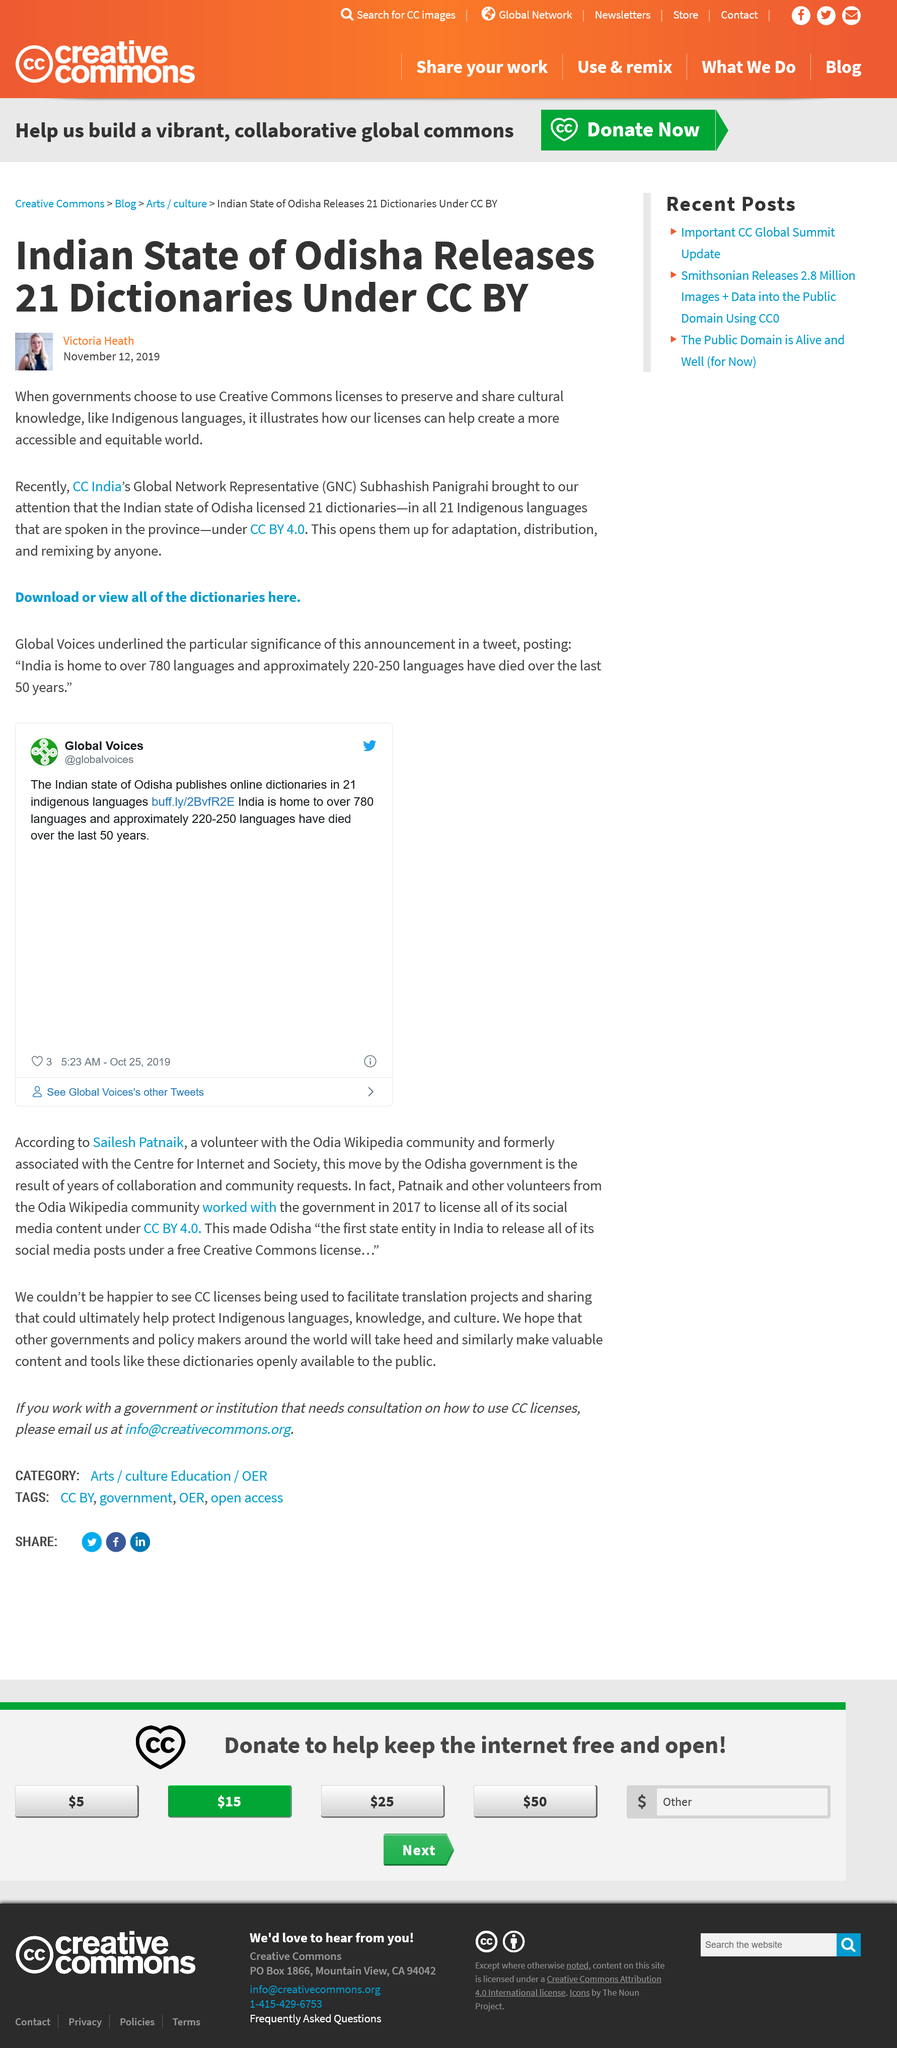Outline some significant characteristics in this image. Odisha, the Indian state, is a forerunner in making their Indigenous languages more accessible. The use of CC licenses open up the dictionaries to allow for the adaptation, distribution, and remixing of their content. In the Indian state of Odisha, 21 Indigenous languages are spoken. 